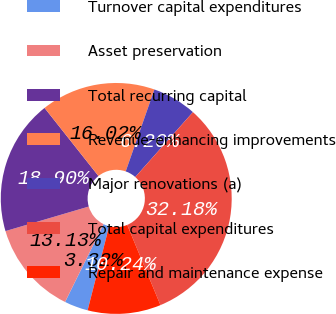Convert chart. <chart><loc_0><loc_0><loc_500><loc_500><pie_chart><fcel>Turnover capital expenditures<fcel>Asset preservation<fcel>Total recurring capital<fcel>Revenue-enhancing improvements<fcel>Major renovations (a)<fcel>Total capital expenditures<fcel>Repair and maintenance expense<nl><fcel>3.32%<fcel>13.13%<fcel>18.9%<fcel>16.02%<fcel>6.2%<fcel>32.18%<fcel>10.24%<nl></chart> 